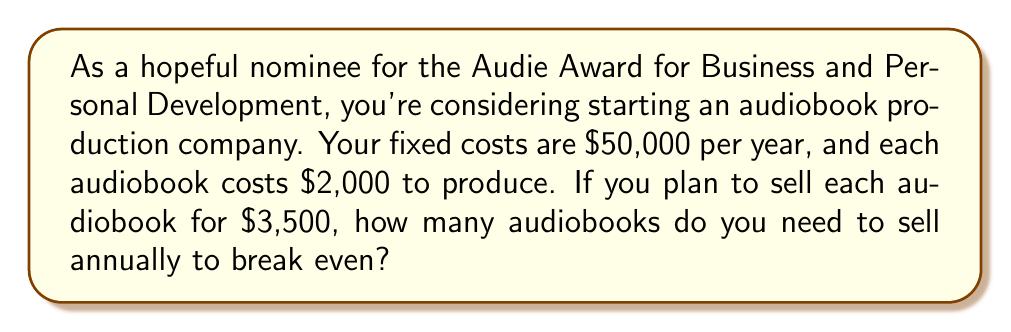Teach me how to tackle this problem. Let's approach this step-by-step:

1) First, let's define our variables:
   $x$ = number of audiobooks sold
   $F$ = fixed costs
   $v$ = variable cost per audiobook
   $p$ = price per audiobook

2) We know:
   $F = \$50,000$
   $v = \$2,000$
   $p = \$3,500$

3) The break-even point occurs when total revenue equals total costs:
   $\text{Total Revenue} = \text{Total Costs}$
   $px = F + vx$

4) Let's substitute our known values:
   $3500x = 50000 + 2000x$

5) Now, let's solve for $x$:
   $3500x - 2000x = 50000$
   $1500x = 50000$

6) Divide both sides by 1500:
   $x = \frac{50000}{1500} = 33.33$

7) Since we can't sell a fraction of an audiobook, we round up to the nearest whole number.
Answer: 34 audiobooks 